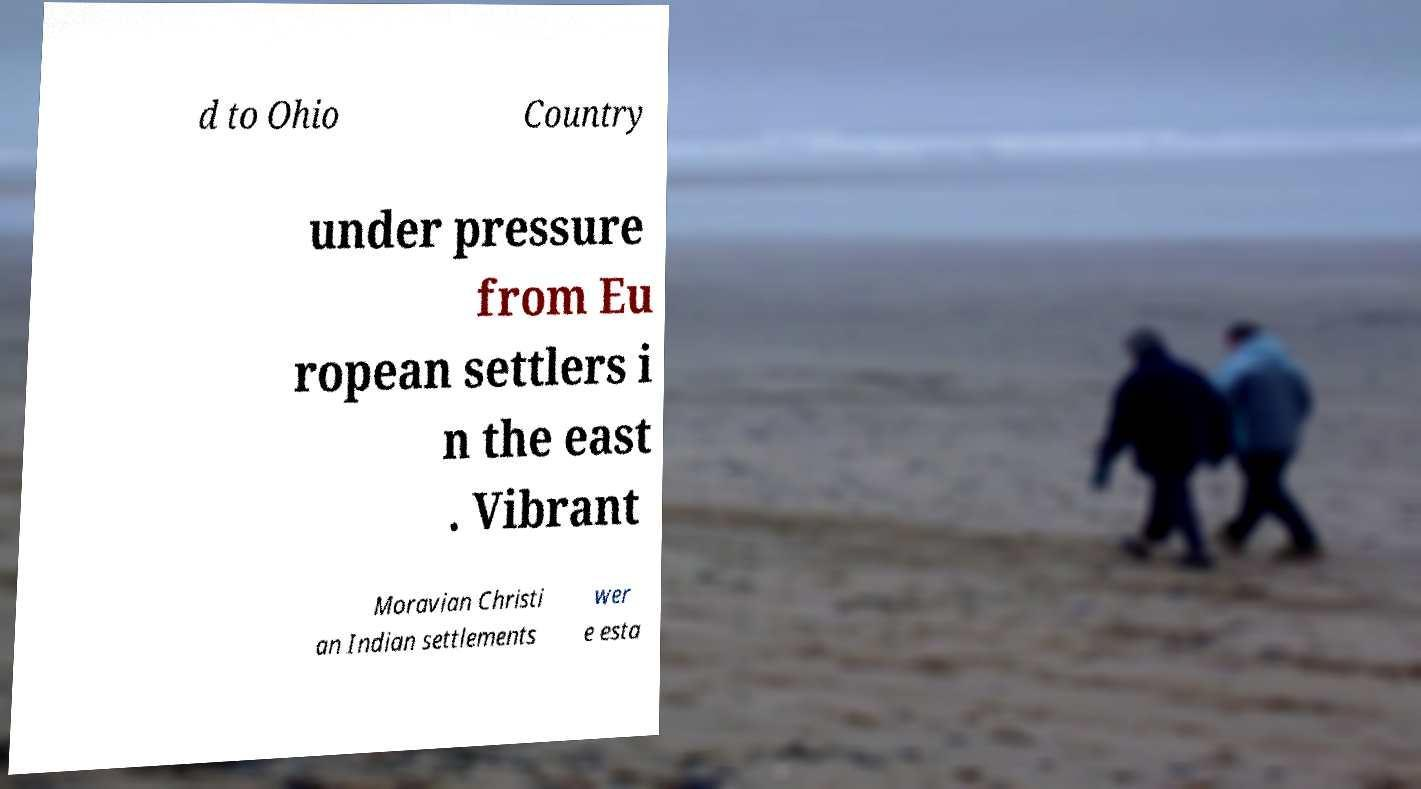For documentation purposes, I need the text within this image transcribed. Could you provide that? d to Ohio Country under pressure from Eu ropean settlers i n the east . Vibrant Moravian Christi an Indian settlements wer e esta 